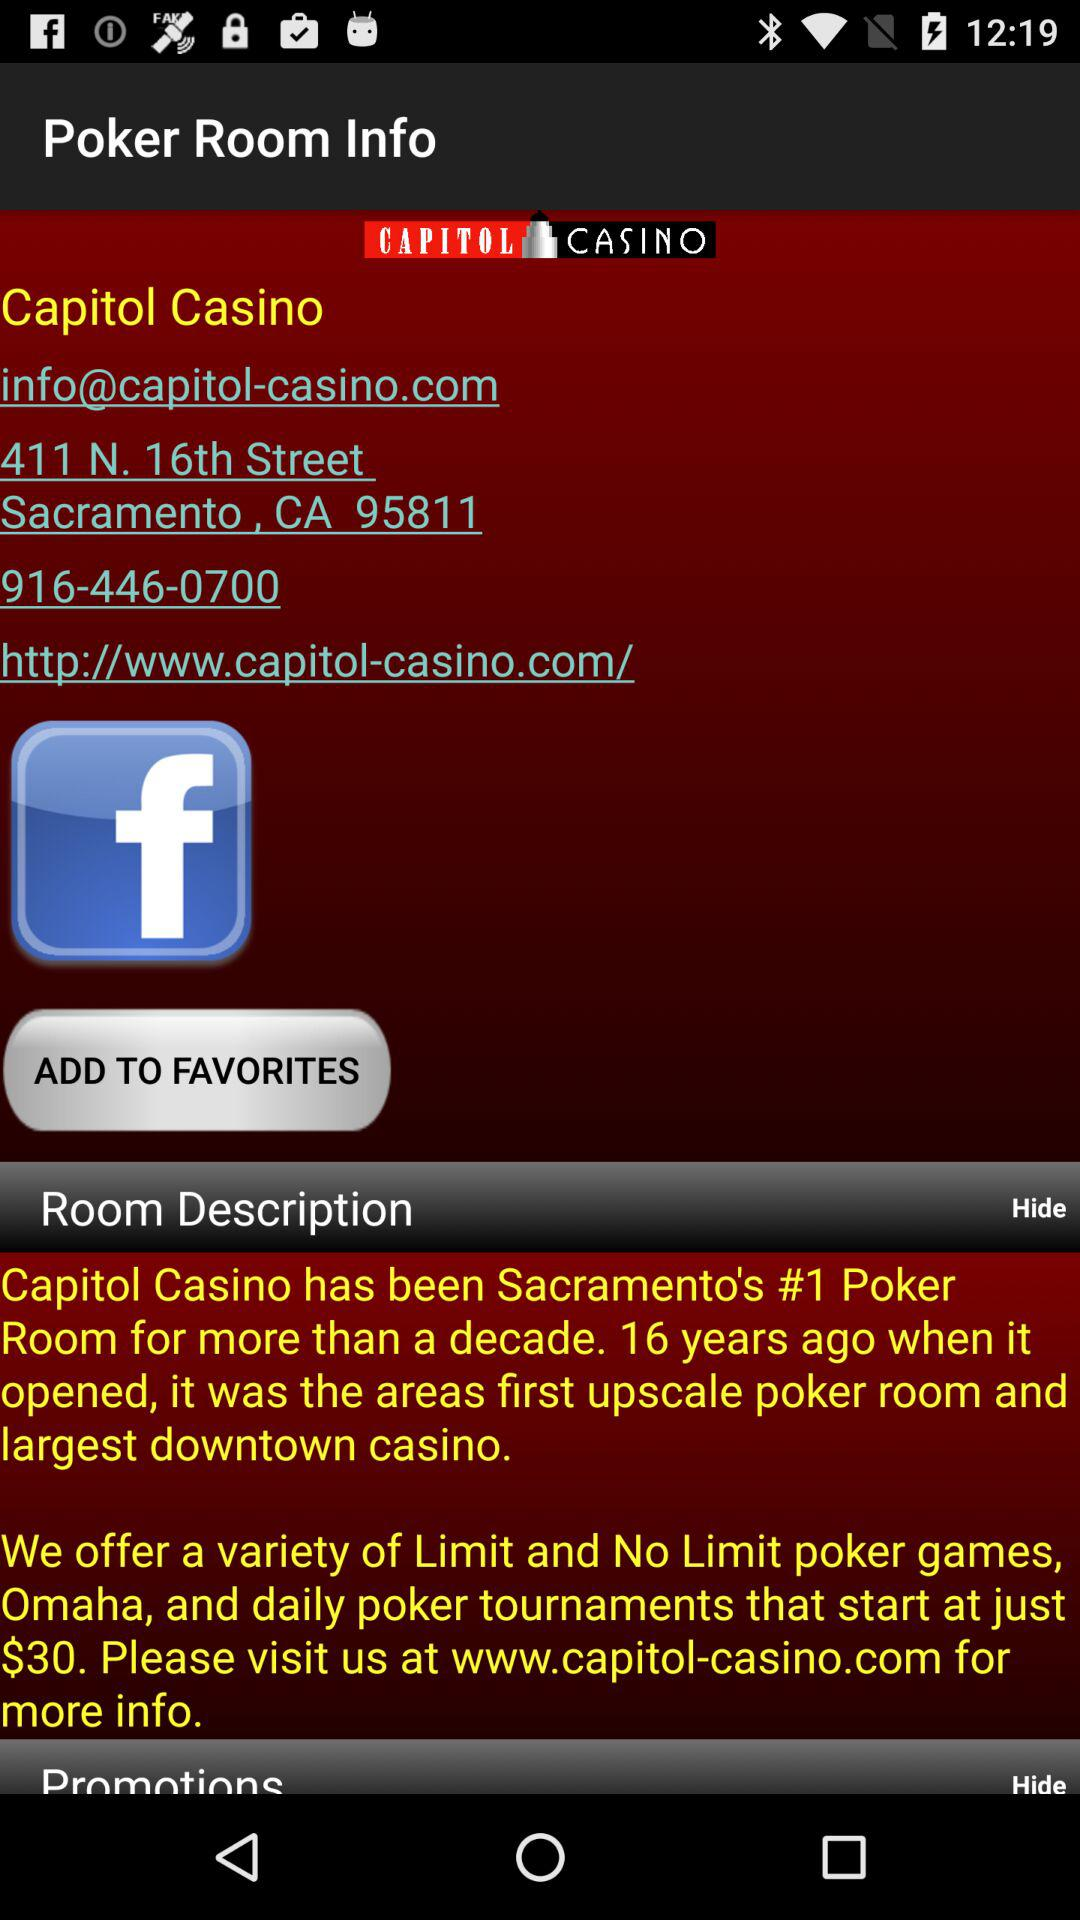What is the contact number? The contact number is 916-446-0700. 